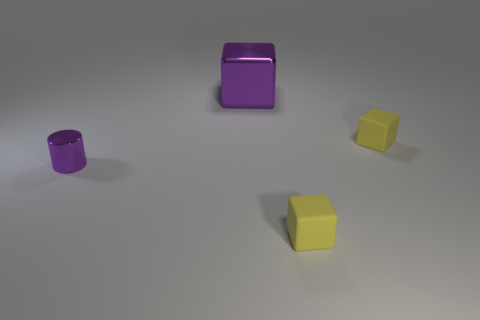Add 4 purple metallic cylinders. How many objects exist? 8 Subtract all cubes. How many objects are left? 1 Subtract 0 blue spheres. How many objects are left? 4 Subtract all large purple things. Subtract all cylinders. How many objects are left? 2 Add 3 small purple things. How many small purple things are left? 4 Add 3 tiny shiny cylinders. How many tiny shiny cylinders exist? 4 